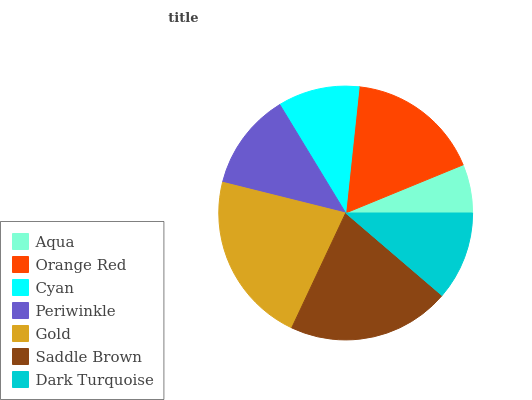Is Aqua the minimum?
Answer yes or no. Yes. Is Gold the maximum?
Answer yes or no. Yes. Is Orange Red the minimum?
Answer yes or no. No. Is Orange Red the maximum?
Answer yes or no. No. Is Orange Red greater than Aqua?
Answer yes or no. Yes. Is Aqua less than Orange Red?
Answer yes or no. Yes. Is Aqua greater than Orange Red?
Answer yes or no. No. Is Orange Red less than Aqua?
Answer yes or no. No. Is Periwinkle the high median?
Answer yes or no. Yes. Is Periwinkle the low median?
Answer yes or no. Yes. Is Saddle Brown the high median?
Answer yes or no. No. Is Dark Turquoise the low median?
Answer yes or no. No. 